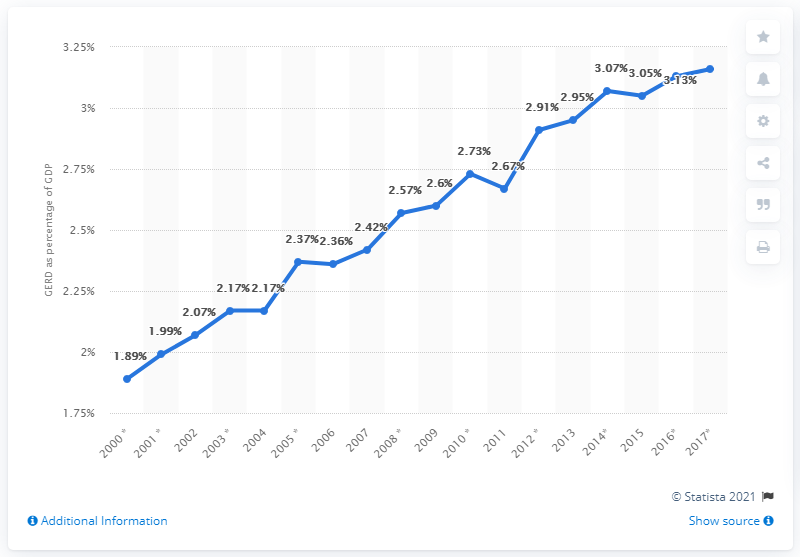Mention a couple of crucial points in this snapshot. In the year 2015, Austria had the highest ratio of Gross External Debt (GERD) to Gross Domestic Product (GDP) among all the years for which data is available. In 2017, GERD accounted for approximately 3.16% of Austria's Gross Domestic Product (GDP). 